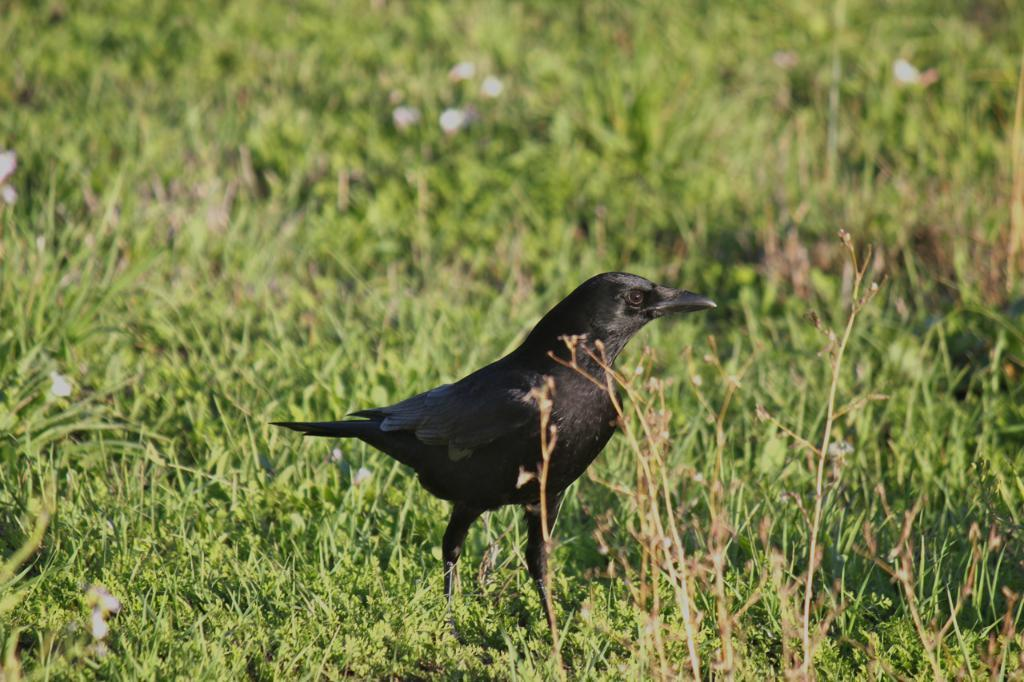What type of bird is in the image? There is a crow in the image. What is the crow standing on? The crow is standing on grasses. What color is the juice being served in the image? There is no juice present in the image; it only features a crow standing on grasses. 